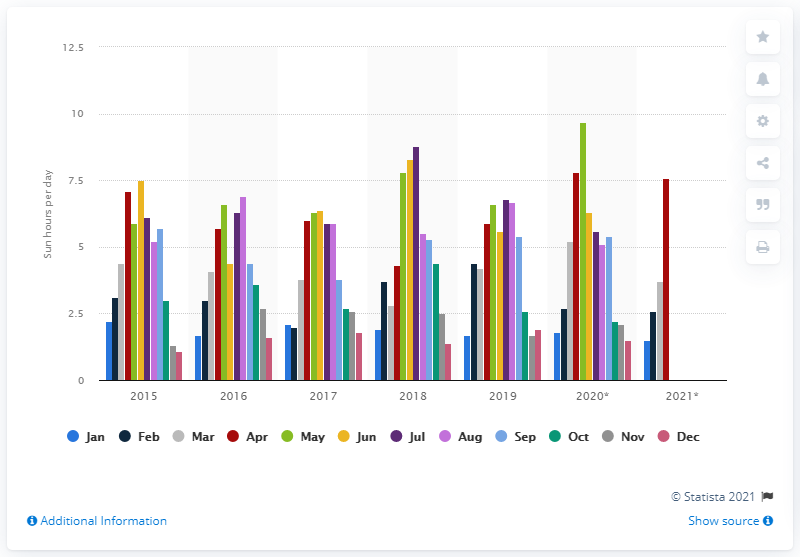Identify some key points in this picture. The average daily sun hours in May 2020 was 9.7. 